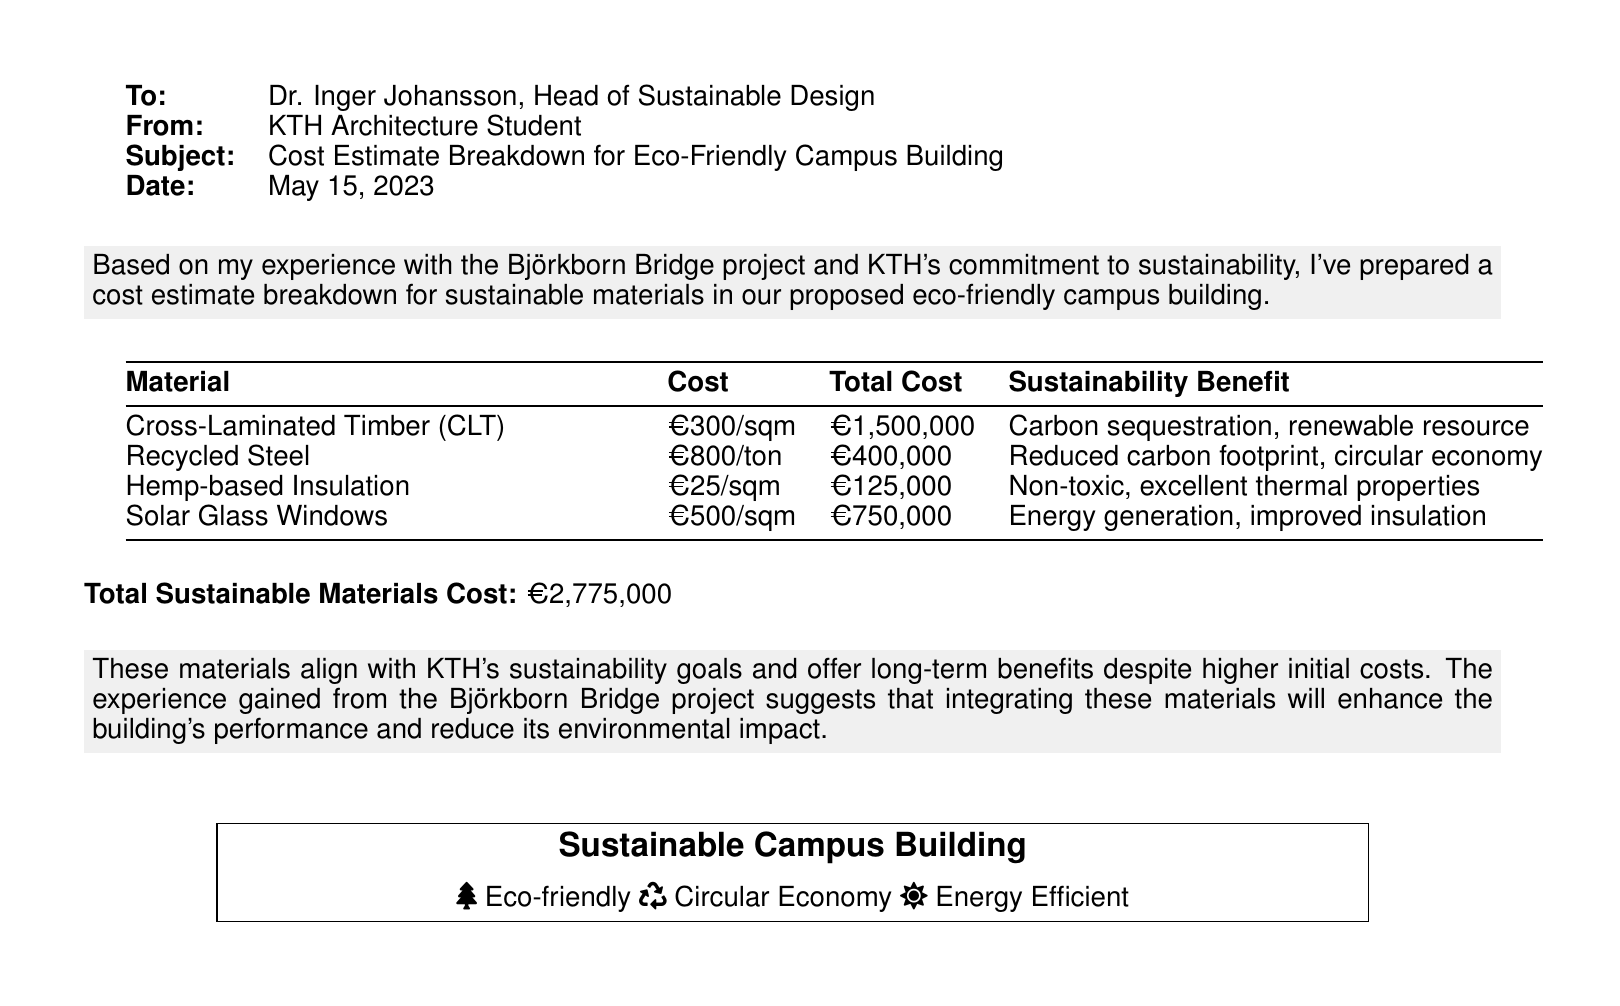what is the subject of the fax? The subject is stated in the document as "Cost Estimate Breakdown for Eco-Friendly Campus Building."
Answer: Cost Estimate Breakdown for Eco-Friendly Campus Building who is the recipient of the fax? The recipient of the fax is mentioned at the beginning of the document as Dr. Inger Johansson.
Answer: Dr. Inger Johansson what is the total cost of the sustainable materials? The total cost is explicitly listed in the document as €2,775,000.
Answer: €2,775,000 how much does Cross-Laminated Timber cost per square meter? The document specifies that Cross-Laminated Timber costs €300 per square meter.
Answer: €300/sqm what is one sustainability benefit of Recycled Steel? The sustainability benefit listed for Recycled Steel is "Reduced carbon footprint."
Answer: Reduced carbon footprint which insulation material is mentioned in the document? The insulation material referenced is Hemp-based Insulation.
Answer: Hemp-based Insulation what type of window is included in the cost estimate? The window type included is Solar Glass Windows.
Answer: Solar Glass Windows how much is earmarked for Hemp-based Insulation? The total earmarked for Hemp-based Insulation is stated as €125,000.
Answer: €125,000 what is the date of the fax? The date is indicated at the beginning of the document as May 15, 2023.
Answer: May 15, 2023 